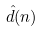Convert formula to latex. <formula><loc_0><loc_0><loc_500><loc_500>\hat { d } ( n )</formula> 